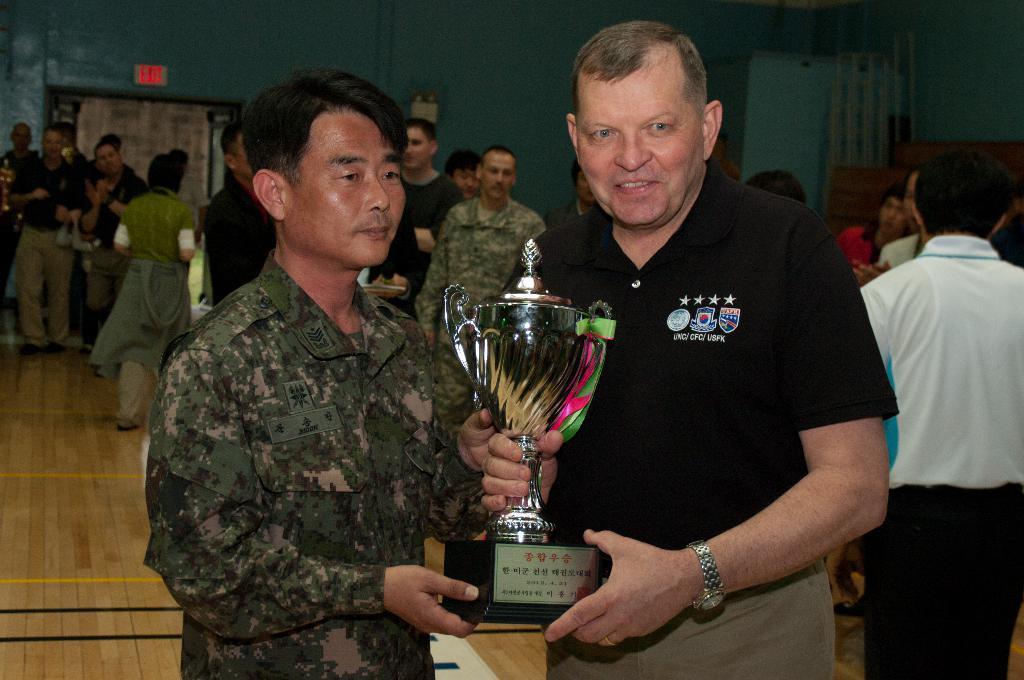Could you give a brief overview of what you see in this image? In this image I can see two persons holding a trophy. In the background there are group of people and there is a wall. Also there are some objects. 